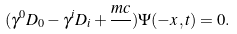Convert formula to latex. <formula><loc_0><loc_0><loc_500><loc_500>( \gamma ^ { 0 } D _ { 0 } - \gamma ^ { i } D _ { i } + \frac { m c } { } ) \Psi ( - x , t ) = 0 .</formula> 